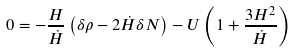<formula> <loc_0><loc_0><loc_500><loc_500>0 = - \frac { H } { \dot { H } } \left ( \delta \rho - 2 \dot { H } \delta N \right ) - U \left ( 1 + \frac { 3 H ^ { 2 } } { \dot { H } } \right )</formula> 